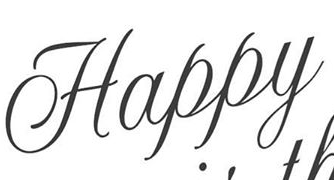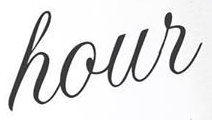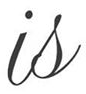Transcribe the words shown in these images in order, separated by a semicolon. Happy; hour; is 